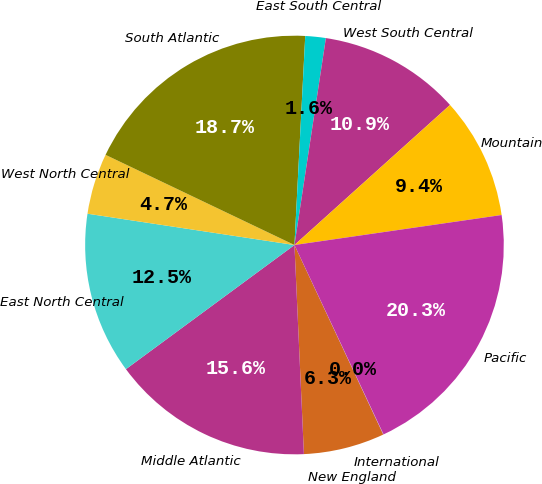Convert chart. <chart><loc_0><loc_0><loc_500><loc_500><pie_chart><fcel>New England<fcel>Middle Atlantic<fcel>East North Central<fcel>West North Central<fcel>South Atlantic<fcel>East South Central<fcel>West South Central<fcel>Mountain<fcel>Pacific<fcel>International<nl><fcel>6.26%<fcel>15.62%<fcel>12.5%<fcel>4.7%<fcel>18.74%<fcel>1.58%<fcel>10.94%<fcel>9.38%<fcel>20.3%<fcel>0.02%<nl></chart> 